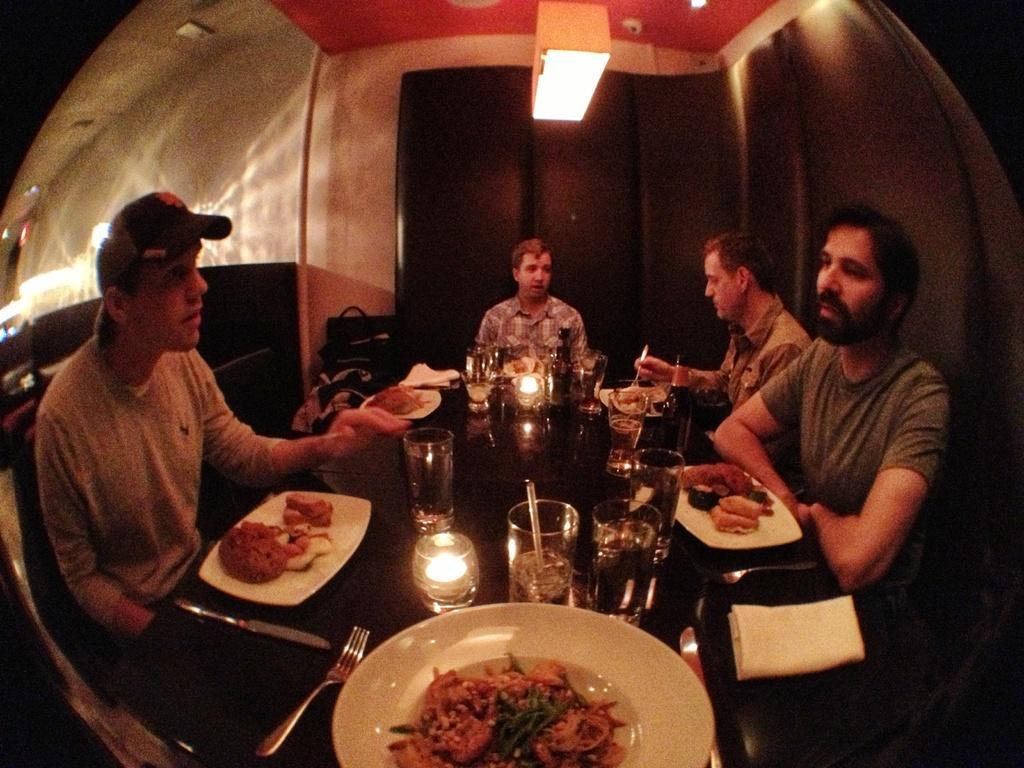How would you summarize this image in a sentence or two? In this image we can see some people sitting on chairs. One man is holding a spoon in his hand. In the center of the image we can see some plates containing food, glasses, spoons, bottles and some candles placed on the table. In the background, we can see some objects placed on the ground. At the top of the image we can see lights on the roof. 